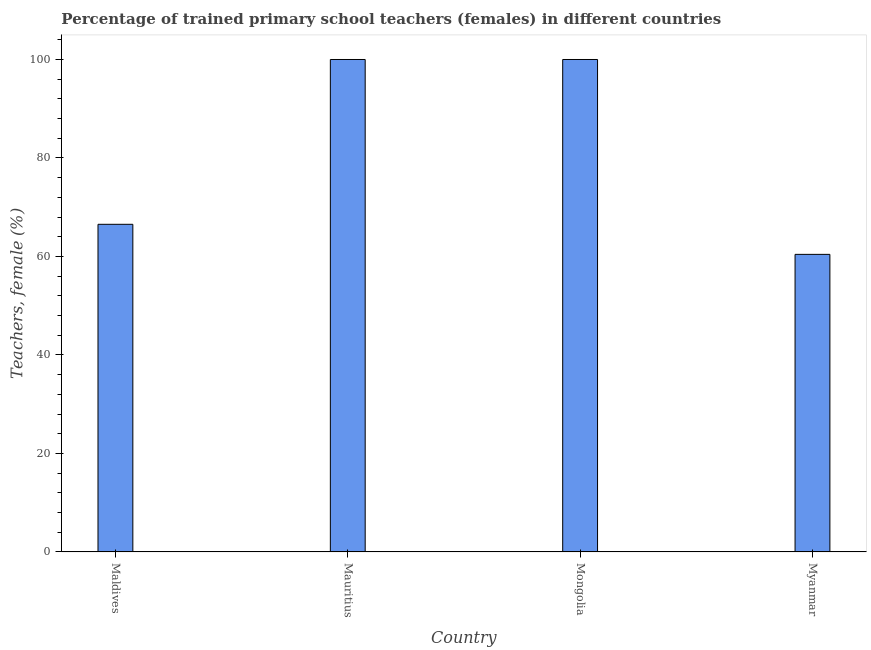Does the graph contain any zero values?
Offer a terse response. No. Does the graph contain grids?
Offer a very short reply. No. What is the title of the graph?
Keep it short and to the point. Percentage of trained primary school teachers (females) in different countries. What is the label or title of the X-axis?
Make the answer very short. Country. What is the label or title of the Y-axis?
Keep it short and to the point. Teachers, female (%). What is the percentage of trained female teachers in Myanmar?
Make the answer very short. 60.43. Across all countries, what is the maximum percentage of trained female teachers?
Ensure brevity in your answer.  100. Across all countries, what is the minimum percentage of trained female teachers?
Provide a succinct answer. 60.43. In which country was the percentage of trained female teachers maximum?
Your answer should be very brief. Mauritius. In which country was the percentage of trained female teachers minimum?
Your answer should be compact. Myanmar. What is the sum of the percentage of trained female teachers?
Ensure brevity in your answer.  326.96. What is the difference between the percentage of trained female teachers in Maldives and Mauritius?
Keep it short and to the point. -33.47. What is the average percentage of trained female teachers per country?
Provide a short and direct response. 81.74. What is the median percentage of trained female teachers?
Ensure brevity in your answer.  83.27. In how many countries, is the percentage of trained female teachers greater than 16 %?
Offer a terse response. 4. What is the ratio of the percentage of trained female teachers in Maldives to that in Mauritius?
Provide a succinct answer. 0.67. Is the percentage of trained female teachers in Mauritius less than that in Mongolia?
Offer a very short reply. No. What is the difference between the highest and the second highest percentage of trained female teachers?
Your response must be concise. 0. What is the difference between the highest and the lowest percentage of trained female teachers?
Your answer should be very brief. 39.57. Are all the bars in the graph horizontal?
Your answer should be very brief. No. What is the difference between two consecutive major ticks on the Y-axis?
Your response must be concise. 20. Are the values on the major ticks of Y-axis written in scientific E-notation?
Your answer should be very brief. No. What is the Teachers, female (%) in Maldives?
Make the answer very short. 66.53. What is the Teachers, female (%) of Mongolia?
Offer a very short reply. 100. What is the Teachers, female (%) of Myanmar?
Your answer should be compact. 60.43. What is the difference between the Teachers, female (%) in Maldives and Mauritius?
Keep it short and to the point. -33.47. What is the difference between the Teachers, female (%) in Maldives and Mongolia?
Your answer should be compact. -33.47. What is the difference between the Teachers, female (%) in Maldives and Myanmar?
Offer a terse response. 6.1. What is the difference between the Teachers, female (%) in Mauritius and Myanmar?
Provide a short and direct response. 39.57. What is the difference between the Teachers, female (%) in Mongolia and Myanmar?
Offer a terse response. 39.57. What is the ratio of the Teachers, female (%) in Maldives to that in Mauritius?
Offer a terse response. 0.67. What is the ratio of the Teachers, female (%) in Maldives to that in Mongolia?
Your response must be concise. 0.67. What is the ratio of the Teachers, female (%) in Maldives to that in Myanmar?
Provide a short and direct response. 1.1. What is the ratio of the Teachers, female (%) in Mauritius to that in Myanmar?
Provide a succinct answer. 1.66. What is the ratio of the Teachers, female (%) in Mongolia to that in Myanmar?
Your answer should be very brief. 1.66. 